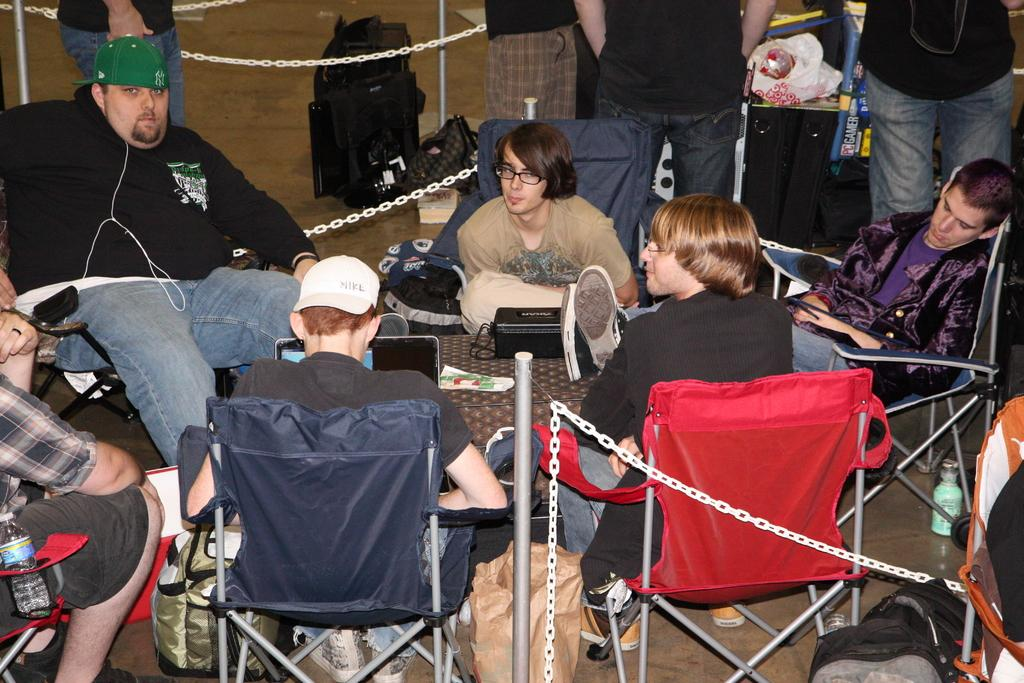What is happening in the image involving a group of people? There is a group of people in the image, and they are sitting on chairs. How are the chairs arranged in the image? The chairs are arranged around a table. What can be found on the table in the image? There are objects on the table. What else can be seen in the background of the image? There are bags visible in the background of the image. What type of cannon is being used by the people in the image? There is no cannon present in the image; it features a group of people sitting on chairs around a table. Can you describe the fangs of the animals in the image? There are no animals with fangs present in the image. 